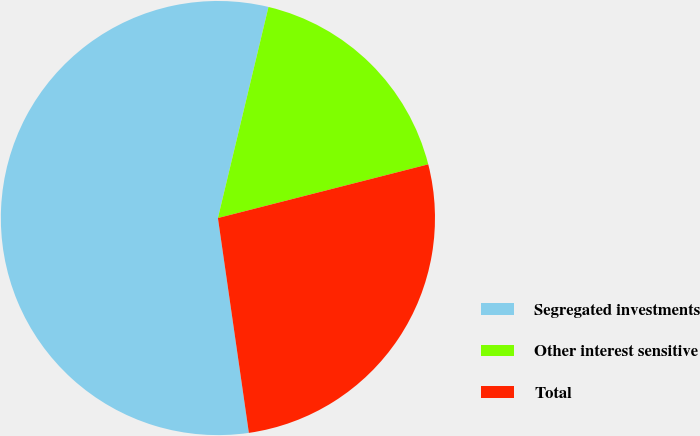Convert chart. <chart><loc_0><loc_0><loc_500><loc_500><pie_chart><fcel>Segregated investments<fcel>Other interest sensitive<fcel>Total<nl><fcel>56.02%<fcel>17.28%<fcel>26.7%<nl></chart> 